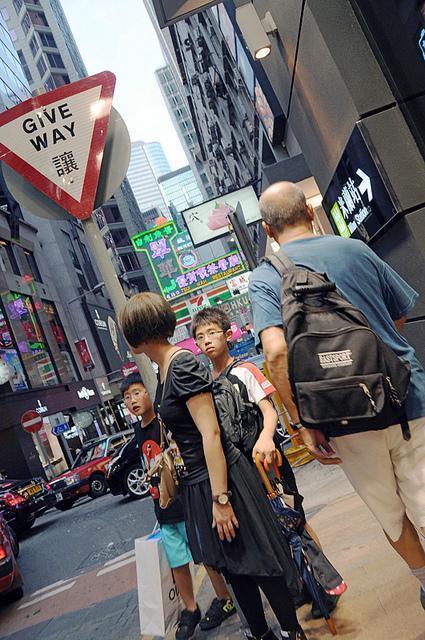The neon signs on the street are located in which city in Asia?
Make your selection from the four choices given to correctly answer the question.
Options: Beijing, hong kong, tokyo, taipei. Hong kong. 